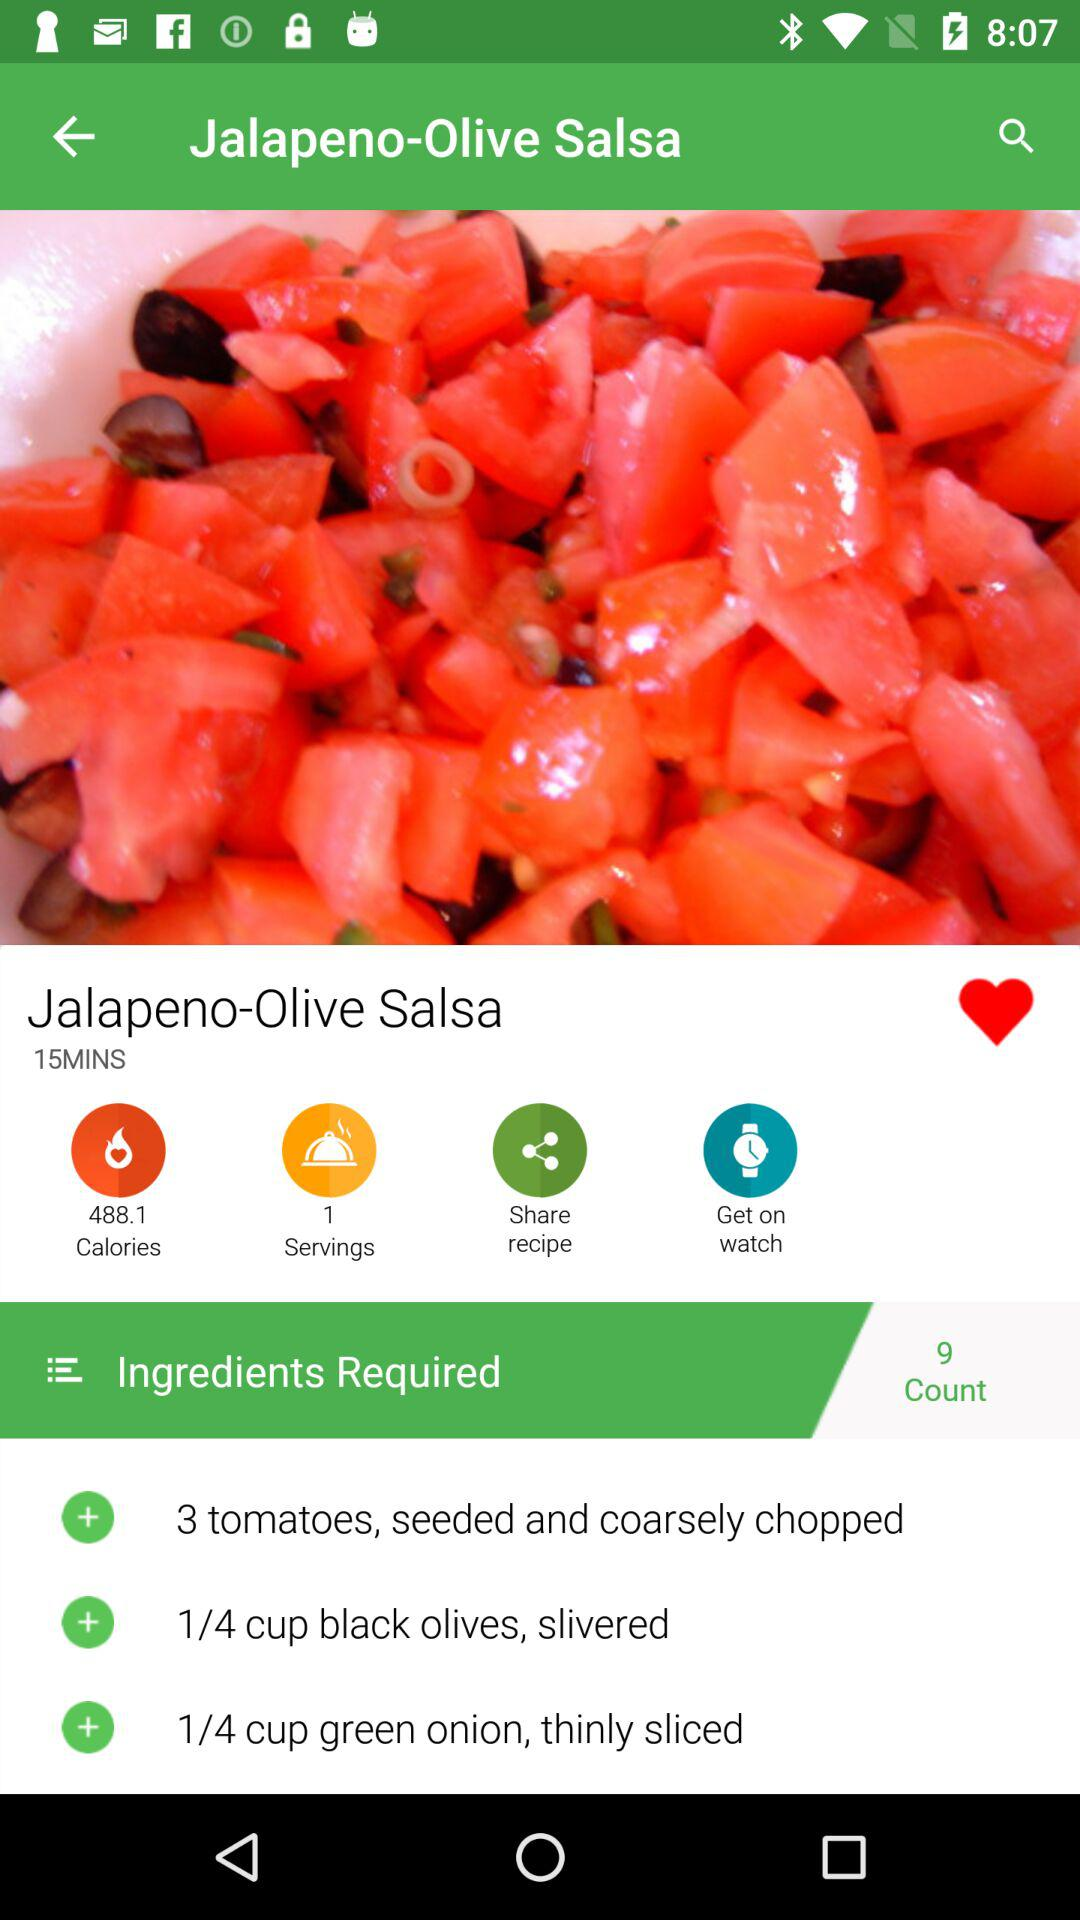How many servings are in this recipe?
Answer the question using a single word or phrase. 1 